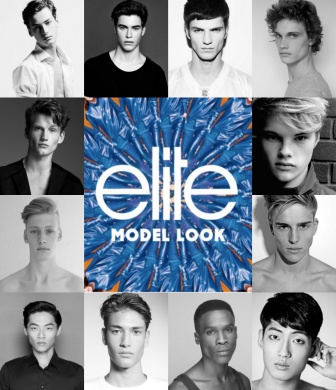Why might the designers have chosen to use a black-and-white theme for the models' headshots? The designers likely chose a black-and-white theme for the models' headshots to create a timeless, classic look that emphasizes the models' features and expressions without distractions. This choice allows for a high contrast against the vibrant central logo, making it stand out more prominently. Additionally, the monochromatic palette lends a sense of sophistication and uniformity, highlighting the models' diversity while maintaining a cohesive visual aesthetic. 